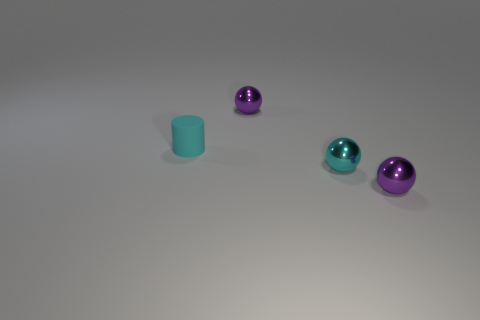How many objects are small cyan shiny objects or purple metal things that are in front of the matte cylinder?
Keep it short and to the point. 2. Is there anything else that has the same material as the small cylinder?
Provide a short and direct response. No. What is the shape of the small shiny object that is the same color as the rubber cylinder?
Provide a succinct answer. Sphere. What is the small cyan ball made of?
Make the answer very short. Metal. What number of rubber things are either small cyan cylinders or tiny purple objects?
Give a very brief answer. 1. What shape is the small cyan object on the left side of the cyan metal sphere?
Offer a very short reply. Cylinder. The object that is on the left side of the tiny cyan metallic object and to the right of the tiny cyan cylinder has what shape?
Give a very brief answer. Sphere. Does the purple object on the right side of the small cyan ball have the same shape as the small purple metal object behind the tiny cyan rubber thing?
Your answer should be very brief. Yes. There is a cyan object in front of the rubber object; how big is it?
Give a very brief answer. Small. What is the size of the cyan metallic thing to the right of the small cyan cylinder on the left side of the cyan sphere?
Give a very brief answer. Small. 